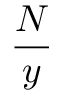Convert formula to latex. <formula><loc_0><loc_0><loc_500><loc_500>\frac { N } { y }</formula> 